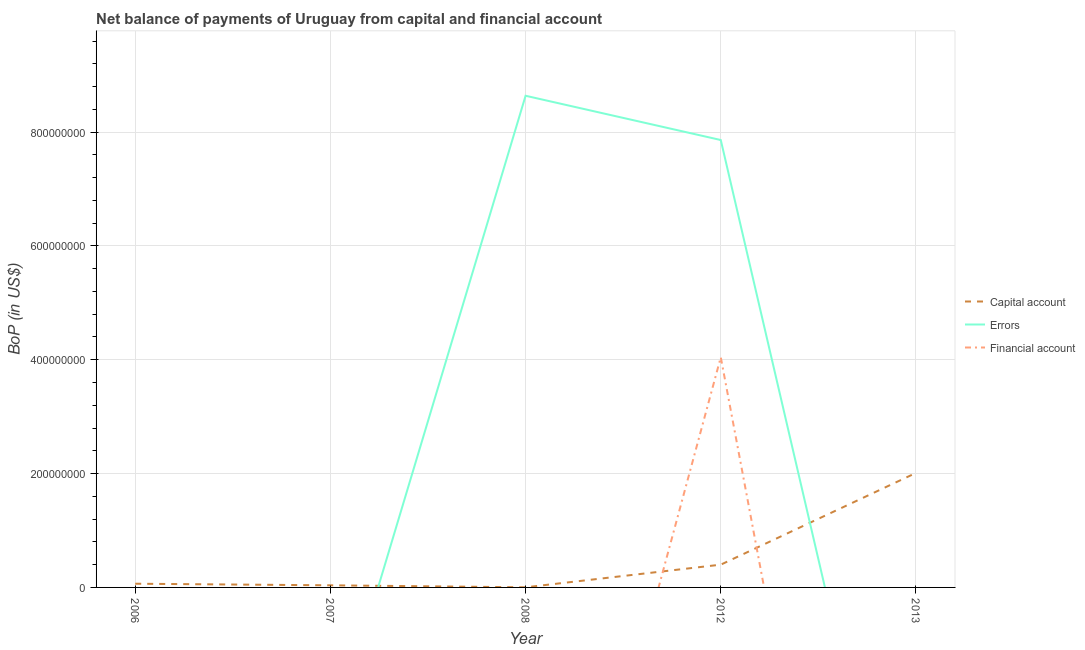How many different coloured lines are there?
Provide a short and direct response. 3. Is the number of lines equal to the number of legend labels?
Offer a very short reply. No. What is the amount of net capital account in 2007?
Your response must be concise. 3.71e+06. Across all years, what is the maximum amount of net capital account?
Offer a very short reply. 2.01e+08. Across all years, what is the minimum amount of financial account?
Your response must be concise. 0. What is the total amount of errors in the graph?
Provide a succinct answer. 1.65e+09. What is the difference between the amount of net capital account in 2007 and that in 2013?
Offer a terse response. -1.97e+08. What is the average amount of net capital account per year?
Offer a very short reply. 5.03e+07. In the year 2012, what is the difference between the amount of errors and amount of net capital account?
Offer a very short reply. 7.46e+08. Is the amount of net capital account in 2012 less than that in 2013?
Make the answer very short. Yes. What is the difference between the highest and the lowest amount of financial account?
Your response must be concise. 4.04e+08. Is the amount of financial account strictly less than the amount of errors over the years?
Ensure brevity in your answer.  Yes. How many years are there in the graph?
Make the answer very short. 5. What is the difference between two consecutive major ticks on the Y-axis?
Give a very brief answer. 2.00e+08. Are the values on the major ticks of Y-axis written in scientific E-notation?
Your answer should be compact. No. Where does the legend appear in the graph?
Provide a short and direct response. Center right. How many legend labels are there?
Provide a succinct answer. 3. How are the legend labels stacked?
Ensure brevity in your answer.  Vertical. What is the title of the graph?
Provide a short and direct response. Net balance of payments of Uruguay from capital and financial account. What is the label or title of the X-axis?
Give a very brief answer. Year. What is the label or title of the Y-axis?
Provide a short and direct response. BoP (in US$). What is the BoP (in US$) of Capital account in 2006?
Give a very brief answer. 6.51e+06. What is the BoP (in US$) of Errors in 2006?
Provide a short and direct response. 0. What is the BoP (in US$) of Financial account in 2006?
Your answer should be compact. 0. What is the BoP (in US$) in Capital account in 2007?
Offer a very short reply. 3.71e+06. What is the BoP (in US$) in Financial account in 2007?
Make the answer very short. 0. What is the BoP (in US$) in Capital account in 2008?
Your answer should be very brief. 2.14e+05. What is the BoP (in US$) in Errors in 2008?
Give a very brief answer. 8.64e+08. What is the BoP (in US$) in Financial account in 2008?
Ensure brevity in your answer.  0. What is the BoP (in US$) in Capital account in 2012?
Provide a succinct answer. 4.00e+07. What is the BoP (in US$) in Errors in 2012?
Give a very brief answer. 7.86e+08. What is the BoP (in US$) in Financial account in 2012?
Offer a terse response. 4.04e+08. What is the BoP (in US$) of Capital account in 2013?
Your response must be concise. 2.01e+08. Across all years, what is the maximum BoP (in US$) in Capital account?
Ensure brevity in your answer.  2.01e+08. Across all years, what is the maximum BoP (in US$) of Errors?
Give a very brief answer. 8.64e+08. Across all years, what is the maximum BoP (in US$) of Financial account?
Make the answer very short. 4.04e+08. Across all years, what is the minimum BoP (in US$) in Capital account?
Keep it short and to the point. 2.14e+05. What is the total BoP (in US$) in Capital account in the graph?
Offer a terse response. 2.52e+08. What is the total BoP (in US$) in Errors in the graph?
Offer a very short reply. 1.65e+09. What is the total BoP (in US$) of Financial account in the graph?
Keep it short and to the point. 4.04e+08. What is the difference between the BoP (in US$) in Capital account in 2006 and that in 2007?
Offer a very short reply. 2.80e+06. What is the difference between the BoP (in US$) of Capital account in 2006 and that in 2008?
Offer a very short reply. 6.29e+06. What is the difference between the BoP (in US$) of Capital account in 2006 and that in 2012?
Provide a succinct answer. -3.35e+07. What is the difference between the BoP (in US$) of Capital account in 2006 and that in 2013?
Offer a terse response. -1.95e+08. What is the difference between the BoP (in US$) in Capital account in 2007 and that in 2008?
Your answer should be very brief. 3.49e+06. What is the difference between the BoP (in US$) of Capital account in 2007 and that in 2012?
Your answer should be compact. -3.63e+07. What is the difference between the BoP (in US$) of Capital account in 2007 and that in 2013?
Keep it short and to the point. -1.97e+08. What is the difference between the BoP (in US$) in Capital account in 2008 and that in 2012?
Offer a terse response. -3.98e+07. What is the difference between the BoP (in US$) in Errors in 2008 and that in 2012?
Provide a short and direct response. 7.78e+07. What is the difference between the BoP (in US$) of Capital account in 2008 and that in 2013?
Make the answer very short. -2.01e+08. What is the difference between the BoP (in US$) in Capital account in 2012 and that in 2013?
Your response must be concise. -1.61e+08. What is the difference between the BoP (in US$) of Capital account in 2006 and the BoP (in US$) of Errors in 2008?
Offer a very short reply. -8.57e+08. What is the difference between the BoP (in US$) of Capital account in 2006 and the BoP (in US$) of Errors in 2012?
Offer a terse response. -7.80e+08. What is the difference between the BoP (in US$) in Capital account in 2006 and the BoP (in US$) in Financial account in 2012?
Your answer should be compact. -3.98e+08. What is the difference between the BoP (in US$) of Capital account in 2007 and the BoP (in US$) of Errors in 2008?
Offer a very short reply. -8.60e+08. What is the difference between the BoP (in US$) in Capital account in 2007 and the BoP (in US$) in Errors in 2012?
Your answer should be very brief. -7.82e+08. What is the difference between the BoP (in US$) in Capital account in 2007 and the BoP (in US$) in Financial account in 2012?
Offer a very short reply. -4.01e+08. What is the difference between the BoP (in US$) of Capital account in 2008 and the BoP (in US$) of Errors in 2012?
Your answer should be very brief. -7.86e+08. What is the difference between the BoP (in US$) in Capital account in 2008 and the BoP (in US$) in Financial account in 2012?
Offer a very short reply. -4.04e+08. What is the difference between the BoP (in US$) in Errors in 2008 and the BoP (in US$) in Financial account in 2012?
Provide a short and direct response. 4.59e+08. What is the average BoP (in US$) in Capital account per year?
Offer a terse response. 5.03e+07. What is the average BoP (in US$) of Errors per year?
Ensure brevity in your answer.  3.30e+08. What is the average BoP (in US$) of Financial account per year?
Your answer should be compact. 8.09e+07. In the year 2008, what is the difference between the BoP (in US$) of Capital account and BoP (in US$) of Errors?
Provide a short and direct response. -8.64e+08. In the year 2012, what is the difference between the BoP (in US$) of Capital account and BoP (in US$) of Errors?
Your answer should be very brief. -7.46e+08. In the year 2012, what is the difference between the BoP (in US$) in Capital account and BoP (in US$) in Financial account?
Provide a succinct answer. -3.64e+08. In the year 2012, what is the difference between the BoP (in US$) in Errors and BoP (in US$) in Financial account?
Your response must be concise. 3.82e+08. What is the ratio of the BoP (in US$) of Capital account in 2006 to that in 2007?
Make the answer very short. 1.75. What is the ratio of the BoP (in US$) of Capital account in 2006 to that in 2008?
Keep it short and to the point. 30.4. What is the ratio of the BoP (in US$) in Capital account in 2006 to that in 2012?
Your answer should be very brief. 0.16. What is the ratio of the BoP (in US$) in Capital account in 2006 to that in 2013?
Your answer should be compact. 0.03. What is the ratio of the BoP (in US$) in Capital account in 2007 to that in 2008?
Offer a very short reply. 17.33. What is the ratio of the BoP (in US$) of Capital account in 2007 to that in 2012?
Provide a succinct answer. 0.09. What is the ratio of the BoP (in US$) of Capital account in 2007 to that in 2013?
Give a very brief answer. 0.02. What is the ratio of the BoP (in US$) in Capital account in 2008 to that in 2012?
Offer a terse response. 0.01. What is the ratio of the BoP (in US$) in Errors in 2008 to that in 2012?
Provide a succinct answer. 1.1. What is the ratio of the BoP (in US$) in Capital account in 2008 to that in 2013?
Make the answer very short. 0. What is the ratio of the BoP (in US$) of Capital account in 2012 to that in 2013?
Offer a very short reply. 0.2. What is the difference between the highest and the second highest BoP (in US$) in Capital account?
Give a very brief answer. 1.61e+08. What is the difference between the highest and the lowest BoP (in US$) in Capital account?
Keep it short and to the point. 2.01e+08. What is the difference between the highest and the lowest BoP (in US$) of Errors?
Provide a succinct answer. 8.64e+08. What is the difference between the highest and the lowest BoP (in US$) of Financial account?
Your response must be concise. 4.04e+08. 